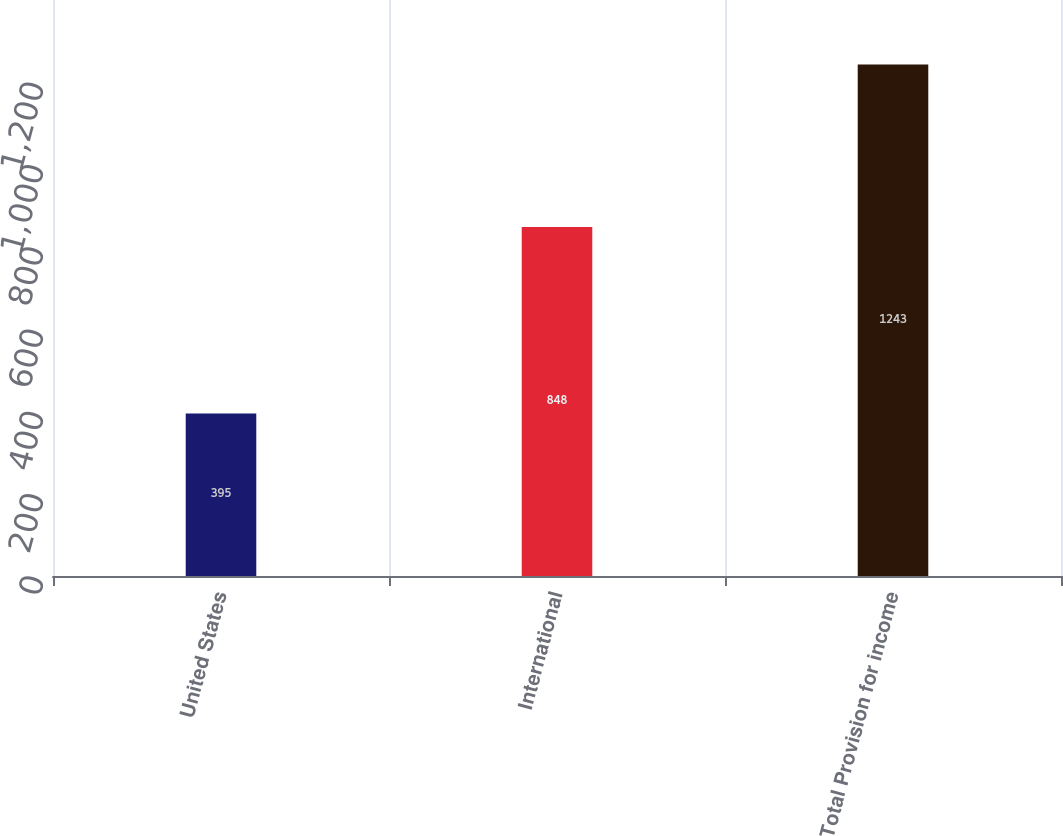<chart> <loc_0><loc_0><loc_500><loc_500><bar_chart><fcel>United States<fcel>International<fcel>Total Provision for income<nl><fcel>395<fcel>848<fcel>1243<nl></chart> 